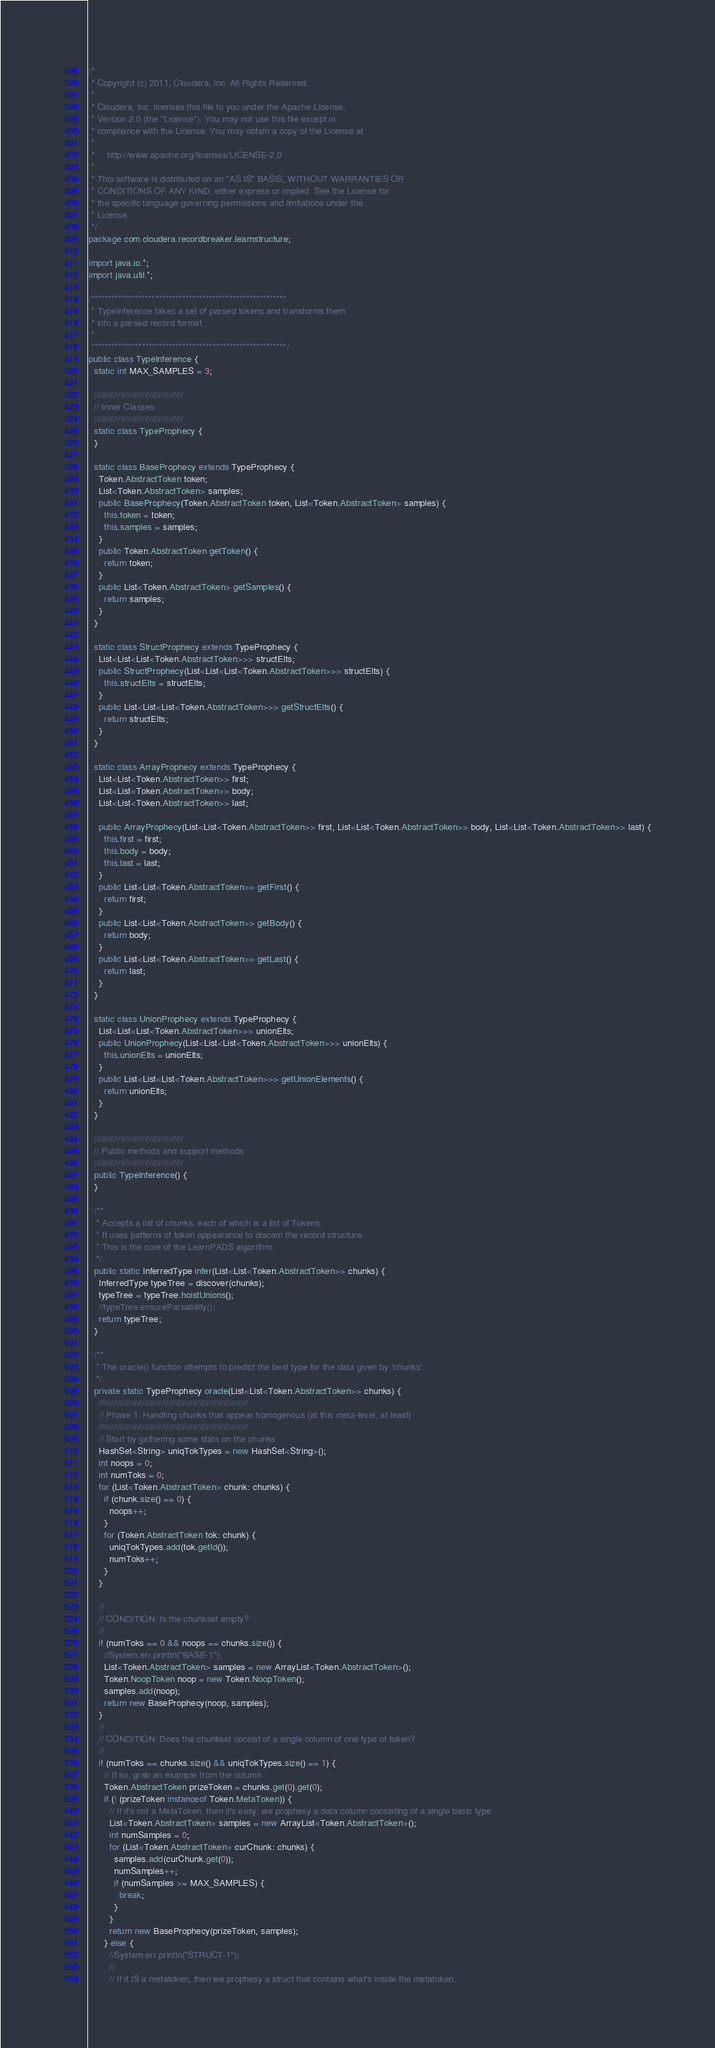Convert code to text. <code><loc_0><loc_0><loc_500><loc_500><_Java_>/*
 * Copyright (c) 2011, Cloudera, Inc. All Rights Reserved.
 *
 * Cloudera, Inc. licenses this file to you under the Apache License,
 * Version 2.0 (the "License"). You may not use this file except in
 * compliance with the License. You may obtain a copy of the License at
 *
 *     http://www.apache.org/licenses/LICENSE-2.0
 *
 * This software is distributed on an "AS IS" BASIS, WITHOUT WARRANTIES OR
 * CONDITIONS OF ANY KIND, either express or implied. See the License for
 * the specific language governing permissions and limitations under the
 * License.
 */
package com.cloudera.recordbreaker.learnstructure;

import java.io.*;
import java.util.*;

/**********************************************************
 * TypeInference takes a set of parsed tokens and transforms them
 * into a parsed record format.
 *
 **********************************************************/
public class TypeInference {
  static int MAX_SAMPLES = 3;

  /////////////////////////////////////
  // Inner Classes
  /////////////////////////////////////
  static class TypeProphecy {
  }

  static class BaseProphecy extends TypeProphecy {
    Token.AbstractToken token;
    List<Token.AbstractToken> samples;
    public BaseProphecy(Token.AbstractToken token, List<Token.AbstractToken> samples) {
      this.token = token;
      this.samples = samples;
    }
    public Token.AbstractToken getToken() {
      return token;
    }
    public List<Token.AbstractToken> getSamples() {
      return samples;
    }
  }

  static class StructProphecy extends TypeProphecy {
    List<List<List<Token.AbstractToken>>> structElts;
    public StructProphecy(List<List<List<Token.AbstractToken>>> structElts) {
      this.structElts = structElts;
    }
    public List<List<List<Token.AbstractToken>>> getStructElts() {
      return structElts;
    }
  }

  static class ArrayProphecy extends TypeProphecy {
    List<List<Token.AbstractToken>> first;
    List<List<Token.AbstractToken>> body;
    List<List<Token.AbstractToken>> last;

    public ArrayProphecy(List<List<Token.AbstractToken>> first, List<List<Token.AbstractToken>> body, List<List<Token.AbstractToken>> last) {
      this.first = first;
      this.body = body;
      this.last = last;
    }
    public List<List<Token.AbstractToken>> getFirst() {
      return first;
    }
    public List<List<Token.AbstractToken>> getBody() {
      return body;
    }
    public List<List<Token.AbstractToken>> getLast() {
      return last;
    }
  }

  static class UnionProphecy extends TypeProphecy {
    List<List<List<Token.AbstractToken>>> unionElts;
    public UnionProphecy(List<List<List<Token.AbstractToken>>> unionElts) {
      this.unionElts = unionElts;
    }
    public List<List<List<Token.AbstractToken>>> getUnionElements() {
      return unionElts;
    }
  }

  /////////////////////////////////////
  // Public methods and support methods
  /////////////////////////////////////
  public TypeInference() {
  }

  /**
   * Accepts a list of chunks, each of which is a list of Tokens.
   * It uses patterns of token appearance to discern the record structure.
   * This is the core of the LearnPADS algorithm.
   */
  public static InferredType infer(List<List<Token.AbstractToken>> chunks) {
    InferredType typeTree = discover(chunks);
    typeTree = typeTree.hoistUnions();
    //typeTree.ensureParsability();
    return typeTree;
  }

  /**
   * The oracle() function attempts to predict the best type for the data given by 'chunks'.
   */
  private static TypeProphecy oracle(List<List<Token.AbstractToken>> chunks) {
    //////////////////////////////////////////////////////////////
    // Phase 1: Handling chunks that appear homogenous (at this meta-level, at least)
    //////////////////////////////////////////////////////////////
    // Start by gathering some stats on the chunks
    HashSet<String> uniqTokTypes = new HashSet<String>();
    int noops = 0;
    int numToks = 0;
    for (List<Token.AbstractToken> chunk: chunks) {
      if (chunk.size() == 0) {
        noops++;
      }
      for (Token.AbstractToken tok: chunk) {
        uniqTokTypes.add(tok.getId());
        numToks++;
      }
    }

    //
    // CONDITION: Is the chunkset empty?
    //
    if (numToks == 0 && noops == chunks.size()) {
      //System.err.println("BASE-1");
      List<Token.AbstractToken> samples = new ArrayList<Token.AbstractToken>();
      Token.NoopToken noop = new Token.NoopToken();
      samples.add(noop);
      return new BaseProphecy(noop, samples);
    }
    //
    // CONDITION: Does the chunkset consist of a single column of one type of token?
    //
    if (numToks == chunks.size() && uniqTokTypes.size() == 1) {
      // If so, grab an example from the column
      Token.AbstractToken prizeToken = chunks.get(0).get(0);
      if (! (prizeToken instanceof Token.MetaToken)) {
        // If it's not a MetaToken, then it's easy: we prophesy a data column consisting of a single basic type
        List<Token.AbstractToken> samples = new ArrayList<Token.AbstractToken>();
        int numSamples = 0;
        for (List<Token.AbstractToken> curChunk: chunks) {
          samples.add(curChunk.get(0));
          numSamples++;
          if (numSamples >= MAX_SAMPLES) {
            break;
          }
        }
        return new BaseProphecy(prizeToken, samples);
      } else {
        //System.err.println("STRUCT-1");
        //
        // If it IS a metatoken, then we prophesy a struct that contains what's inside the metatoken.</code> 